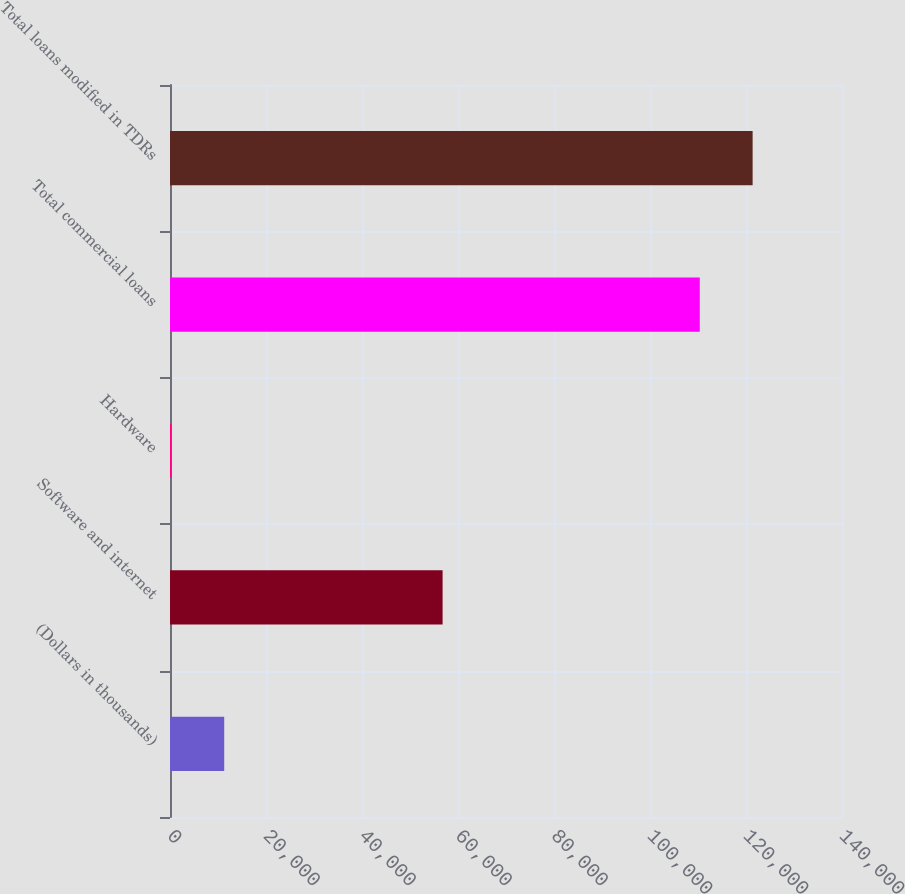<chart> <loc_0><loc_0><loc_500><loc_500><bar_chart><fcel>(Dollars in thousands)<fcel>Software and internet<fcel>Hardware<fcel>Total commercial loans<fcel>Total loans modified in TDRs<nl><fcel>11294.5<fcel>56790<fcel>286<fcel>110371<fcel>121380<nl></chart> 